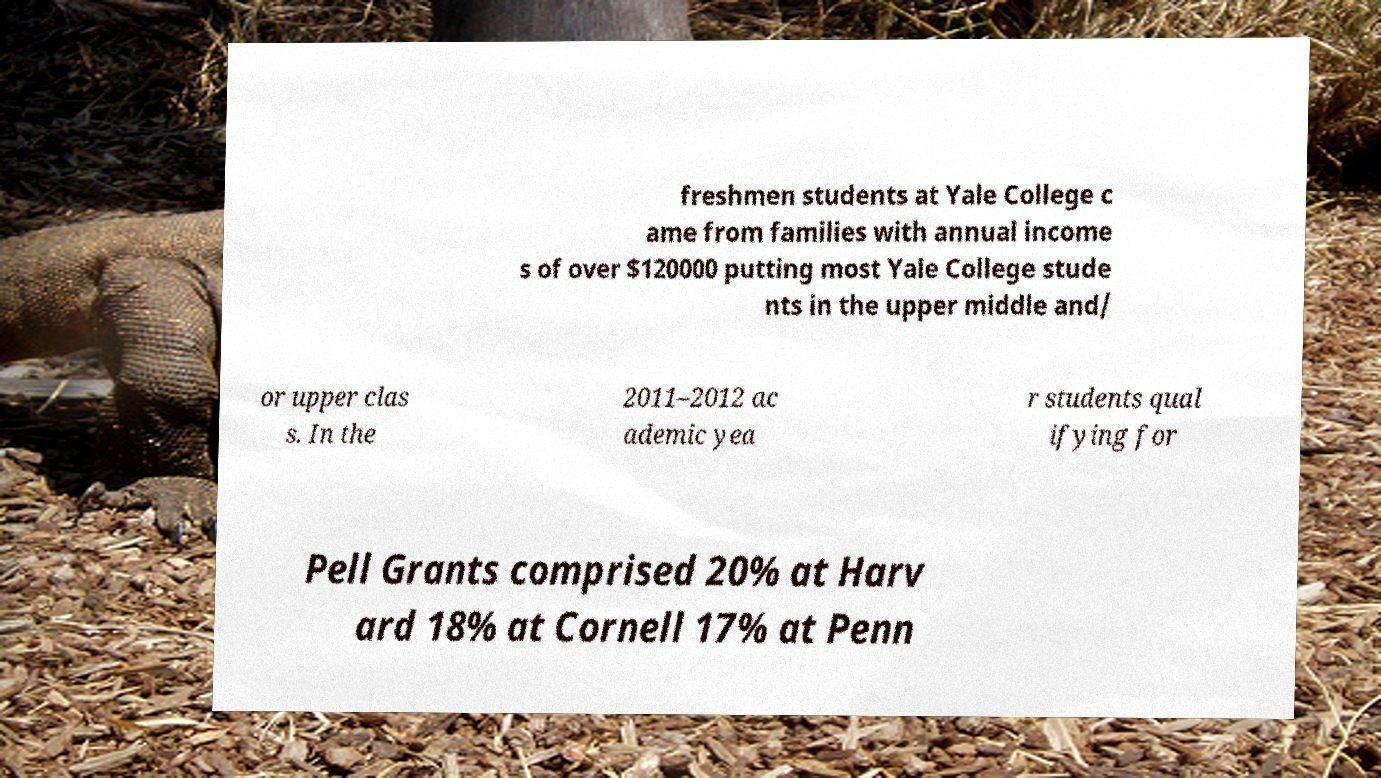There's text embedded in this image that I need extracted. Can you transcribe it verbatim? freshmen students at Yale College c ame from families with annual income s of over $120000 putting most Yale College stude nts in the upper middle and/ or upper clas s. In the 2011–2012 ac ademic yea r students qual ifying for Pell Grants comprised 20% at Harv ard 18% at Cornell 17% at Penn 